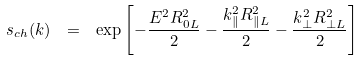<formula> <loc_0><loc_0><loc_500><loc_500>s _ { c h } ( k ) \ = \ \exp \left [ - \frac { E ^ { 2 } R ^ { 2 } _ { 0 L } } { 2 } - \frac { k _ { \| } ^ { 2 } R ^ { 2 } _ { \| L } } { 2 } - \frac { { k } _ { \perp } ^ { 2 } R ^ { 2 } _ { \perp L } } { 2 } \right ]</formula> 